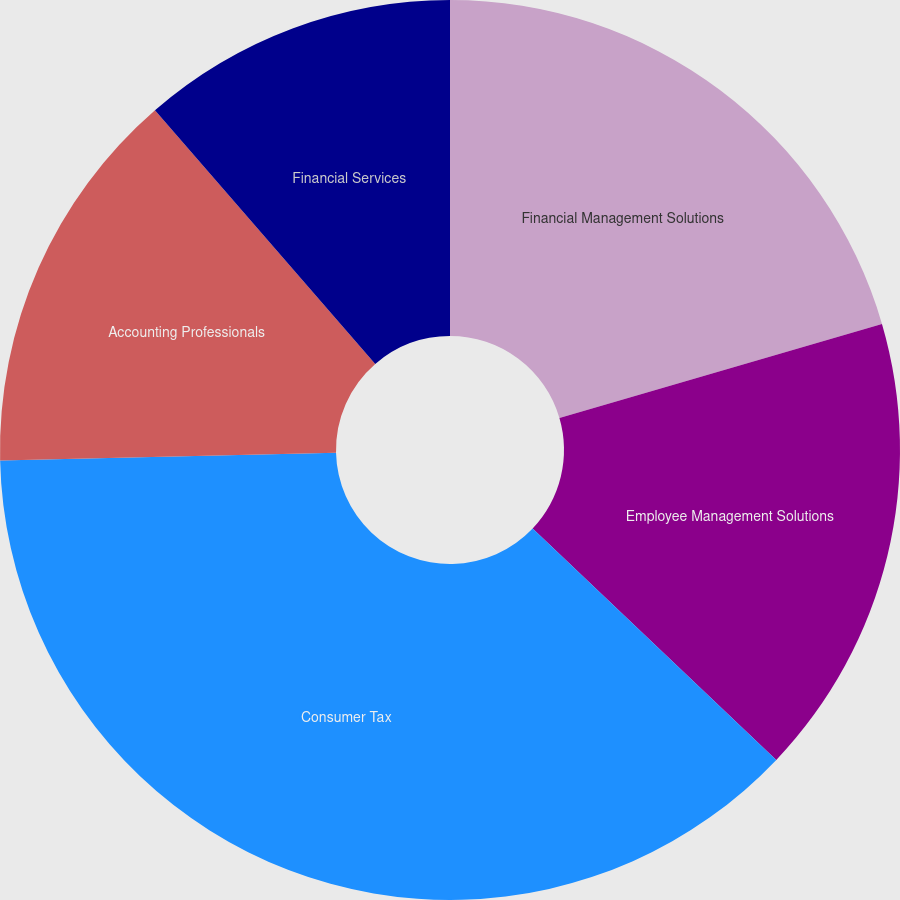Convert chart. <chart><loc_0><loc_0><loc_500><loc_500><pie_chart><fcel>Financial Management Solutions<fcel>Employee Management Solutions<fcel>Consumer Tax<fcel>Accounting Professionals<fcel>Financial Services<nl><fcel>20.48%<fcel>16.61%<fcel>37.54%<fcel>13.99%<fcel>11.38%<nl></chart> 